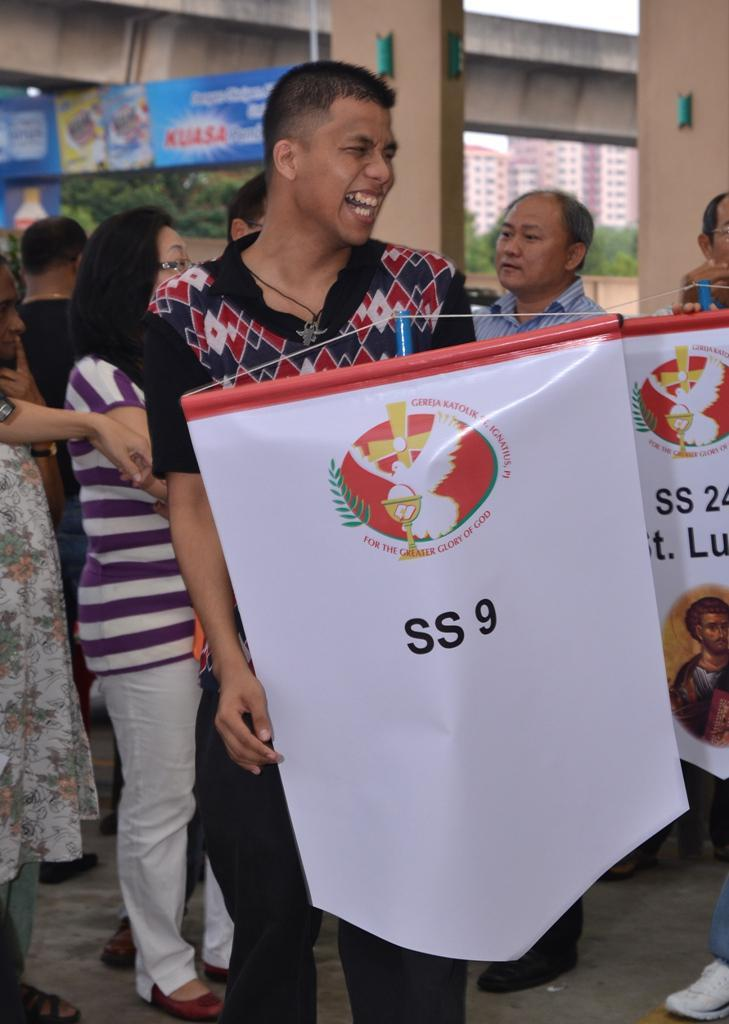Who is the main subject in the image? There is a man in the image. What is the man holding in the image? The man is holding a banner. What is the man's facial expression in the image? The man is laughing. Can you describe the background of the image? There are other people in the background of the image. What type of representative is the man in the image? The image does not indicate that the man is a representative of any organization or group. 